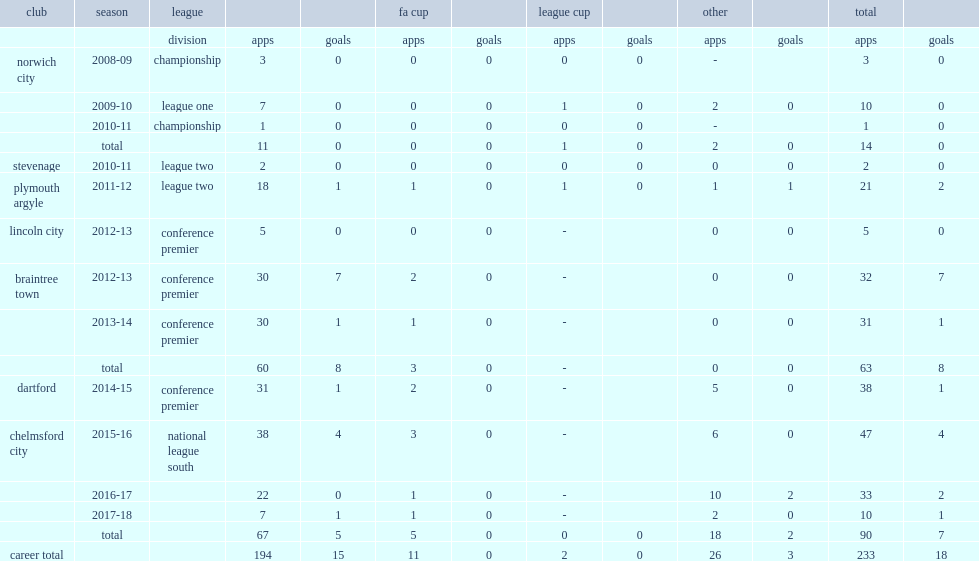In the 2011-12 season, which club did daley play with league two? Plymouth argyle. 